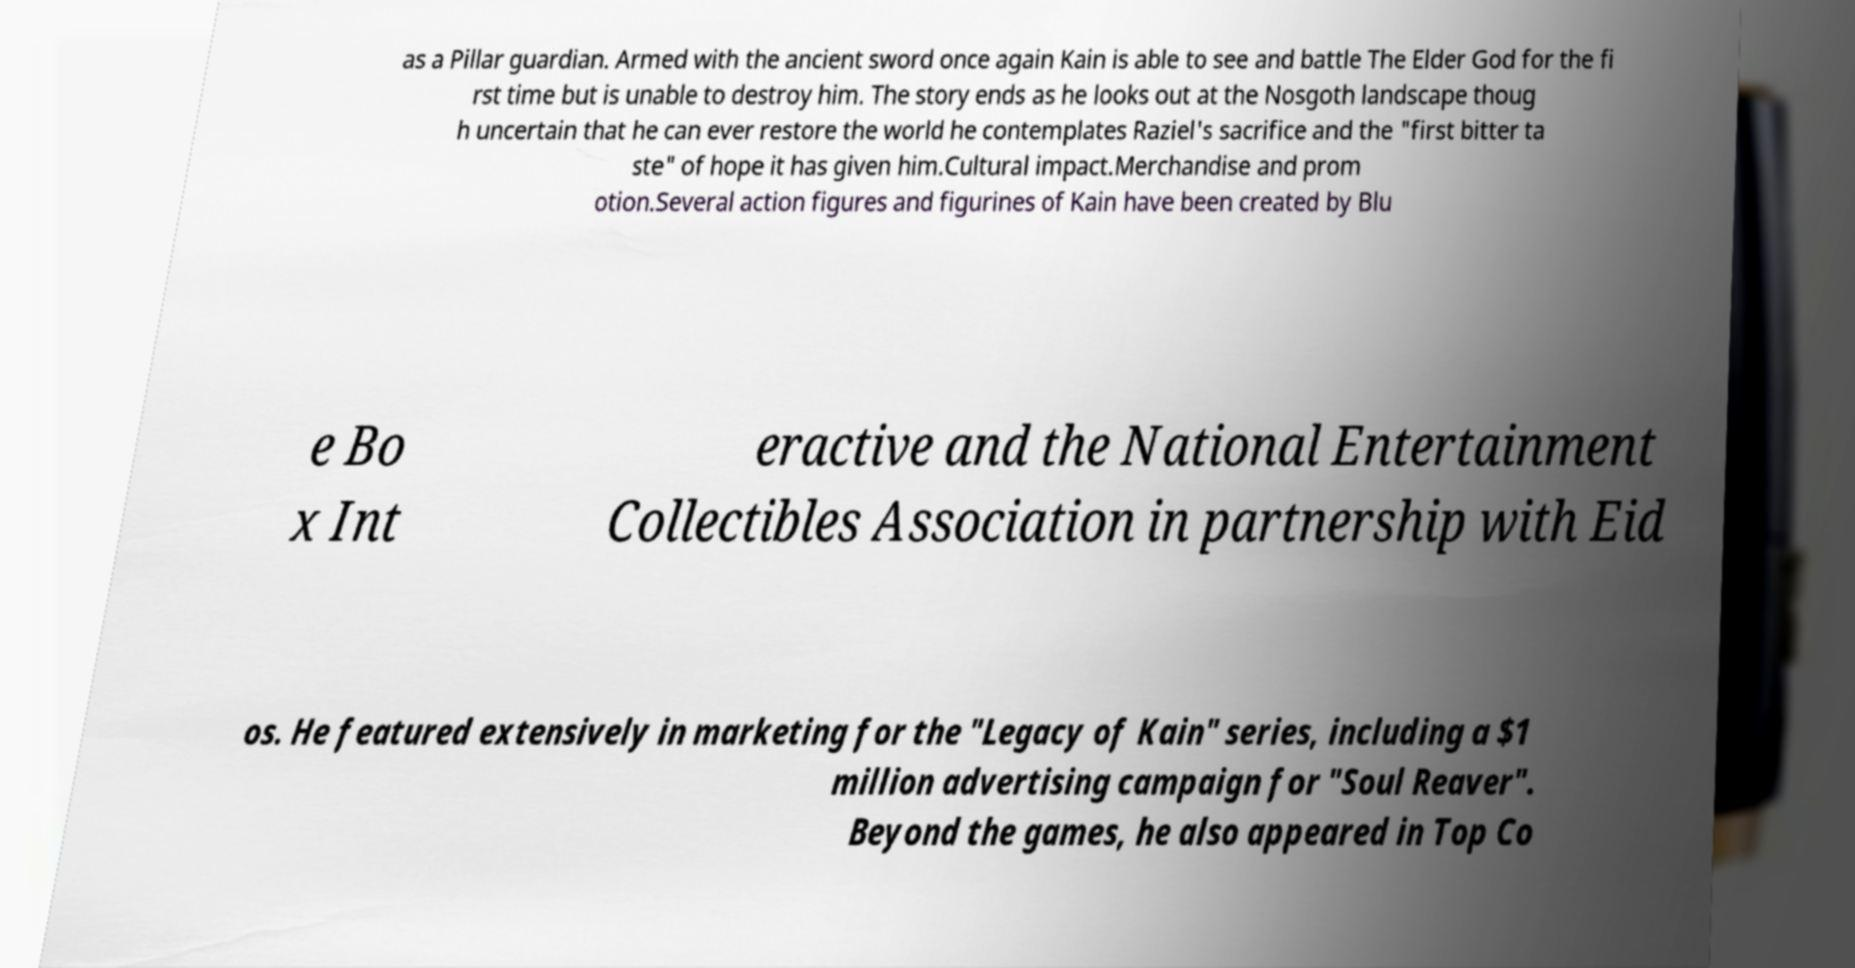Please identify and transcribe the text found in this image. as a Pillar guardian. Armed with the ancient sword once again Kain is able to see and battle The Elder God for the fi rst time but is unable to destroy him. The story ends as he looks out at the Nosgoth landscape thoug h uncertain that he can ever restore the world he contemplates Raziel's sacrifice and the "first bitter ta ste" of hope it has given him.Cultural impact.Merchandise and prom otion.Several action figures and figurines of Kain have been created by Blu e Bo x Int eractive and the National Entertainment Collectibles Association in partnership with Eid os. He featured extensively in marketing for the "Legacy of Kain" series, including a $1 million advertising campaign for "Soul Reaver". Beyond the games, he also appeared in Top Co 